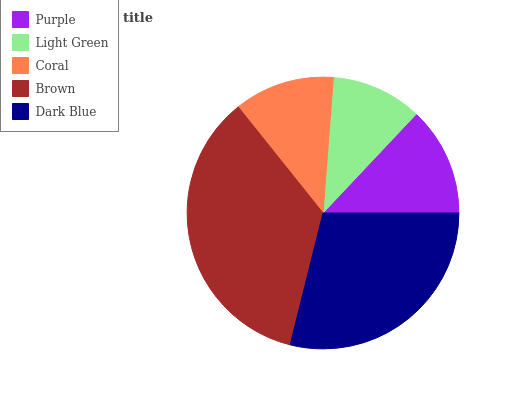Is Light Green the minimum?
Answer yes or no. Yes. Is Brown the maximum?
Answer yes or no. Yes. Is Coral the minimum?
Answer yes or no. No. Is Coral the maximum?
Answer yes or no. No. Is Coral greater than Light Green?
Answer yes or no. Yes. Is Light Green less than Coral?
Answer yes or no. Yes. Is Light Green greater than Coral?
Answer yes or no. No. Is Coral less than Light Green?
Answer yes or no. No. Is Purple the high median?
Answer yes or no. Yes. Is Purple the low median?
Answer yes or no. Yes. Is Coral the high median?
Answer yes or no. No. Is Coral the low median?
Answer yes or no. No. 